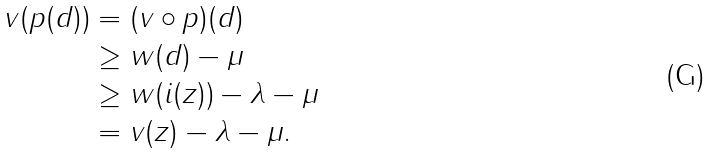Convert formula to latex. <formula><loc_0><loc_0><loc_500><loc_500>v ( p ( d ) ) & = ( v \circ p ) ( d ) \\ & \geq w ( d ) - \mu \\ & \geq w ( i ( z ) ) - \lambda - \mu \\ & = v ( z ) - \lambda - \mu . \\</formula> 